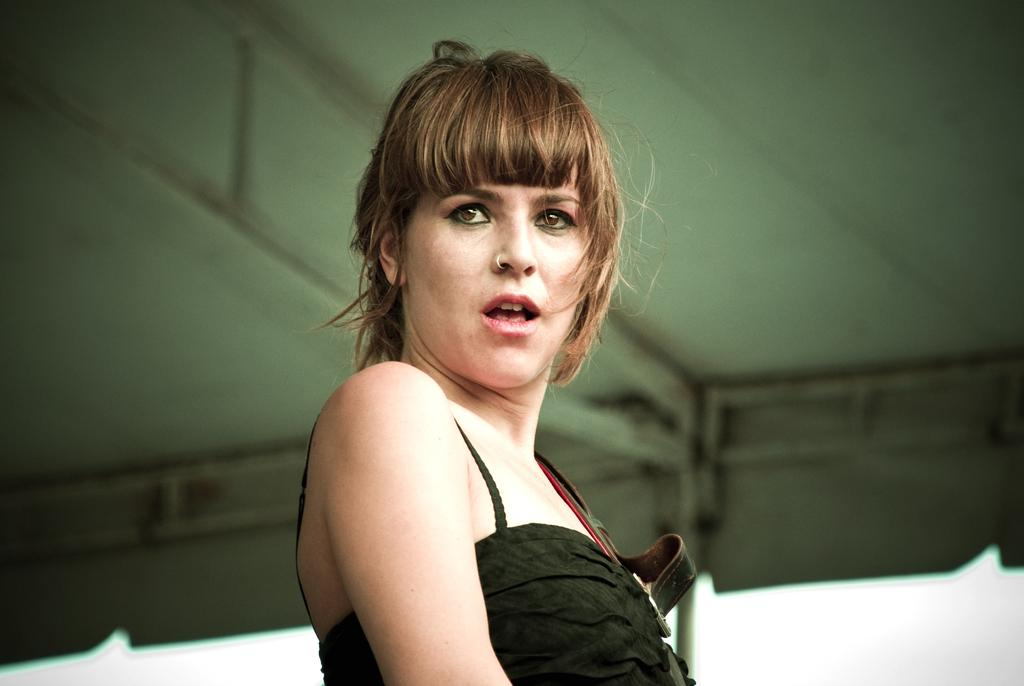What is the main subject of the image? There is a person in the image. Can you describe the person's attire in the image? The person is wearing clothes. What type of gold design can be seen on the person's guide in the image? There is no guide or gold design present in the image. 